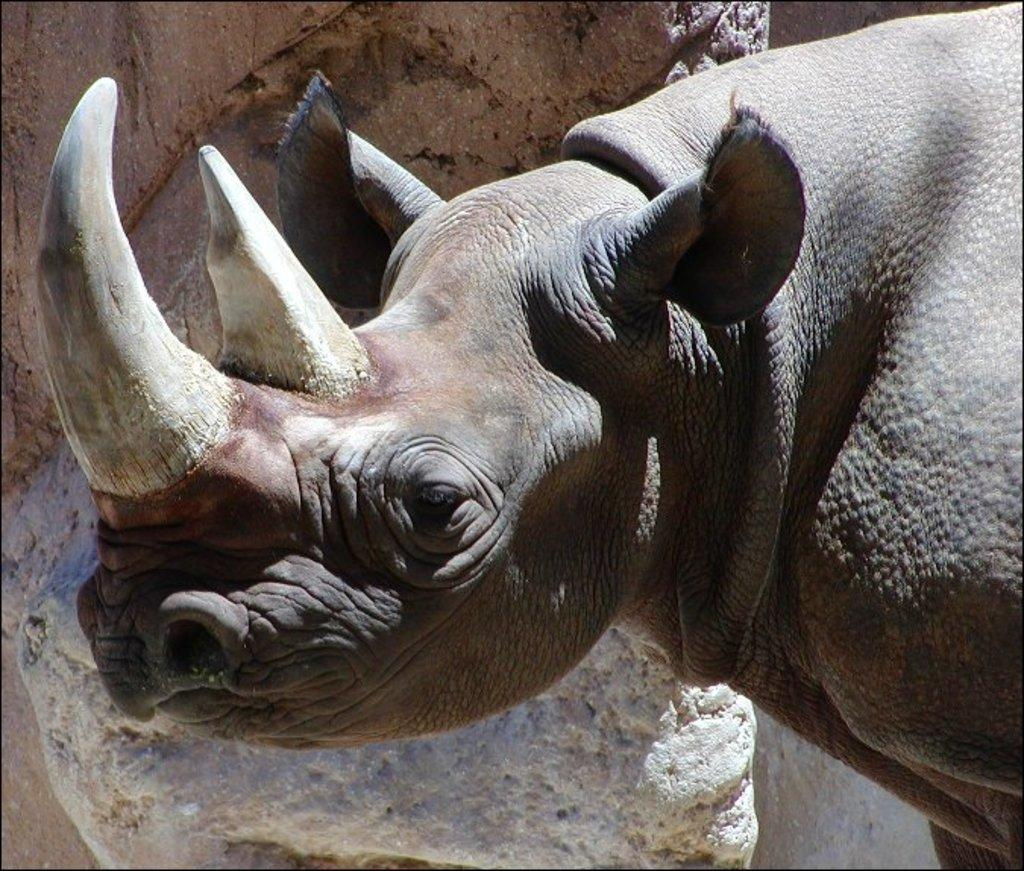What animal is the main subject of the image? There is a rhinoceros in the image. What is the rhinoceros standing in front of? The rhinoceros is in front of a rock. What type of representative is present in the image? There is no representative present in the image; it features a rhinoceros standing in front of a rock. What reward can be seen being given to the rhinoceros in the image? There is no reward being given to the rhinoceros in the image; it is simply standing in front of a rock. 